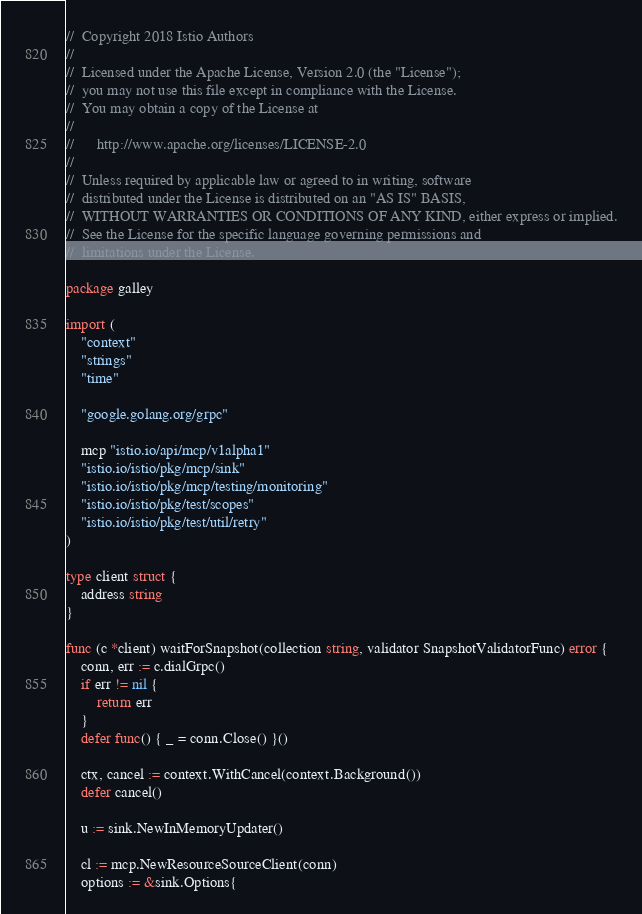<code> <loc_0><loc_0><loc_500><loc_500><_Go_>//  Copyright 2018 Istio Authors
//
//  Licensed under the Apache License, Version 2.0 (the "License");
//  you may not use this file except in compliance with the License.
//  You may obtain a copy of the License at
//
//      http://www.apache.org/licenses/LICENSE-2.0
//
//  Unless required by applicable law or agreed to in writing, software
//  distributed under the License is distributed on an "AS IS" BASIS,
//  WITHOUT WARRANTIES OR CONDITIONS OF ANY KIND, either express or implied.
//  See the License for the specific language governing permissions and
//  limitations under the License.

package galley

import (
	"context"
	"strings"
	"time"

	"google.golang.org/grpc"

	mcp "istio.io/api/mcp/v1alpha1"
	"istio.io/istio/pkg/mcp/sink"
	"istio.io/istio/pkg/mcp/testing/monitoring"
	"istio.io/istio/pkg/test/scopes"
	"istio.io/istio/pkg/test/util/retry"
)

type client struct {
	address string
}

func (c *client) waitForSnapshot(collection string, validator SnapshotValidatorFunc) error {
	conn, err := c.dialGrpc()
	if err != nil {
		return err
	}
	defer func() { _ = conn.Close() }()

	ctx, cancel := context.WithCancel(context.Background())
	defer cancel()

	u := sink.NewInMemoryUpdater()

	cl := mcp.NewResourceSourceClient(conn)
	options := &sink.Options{</code> 